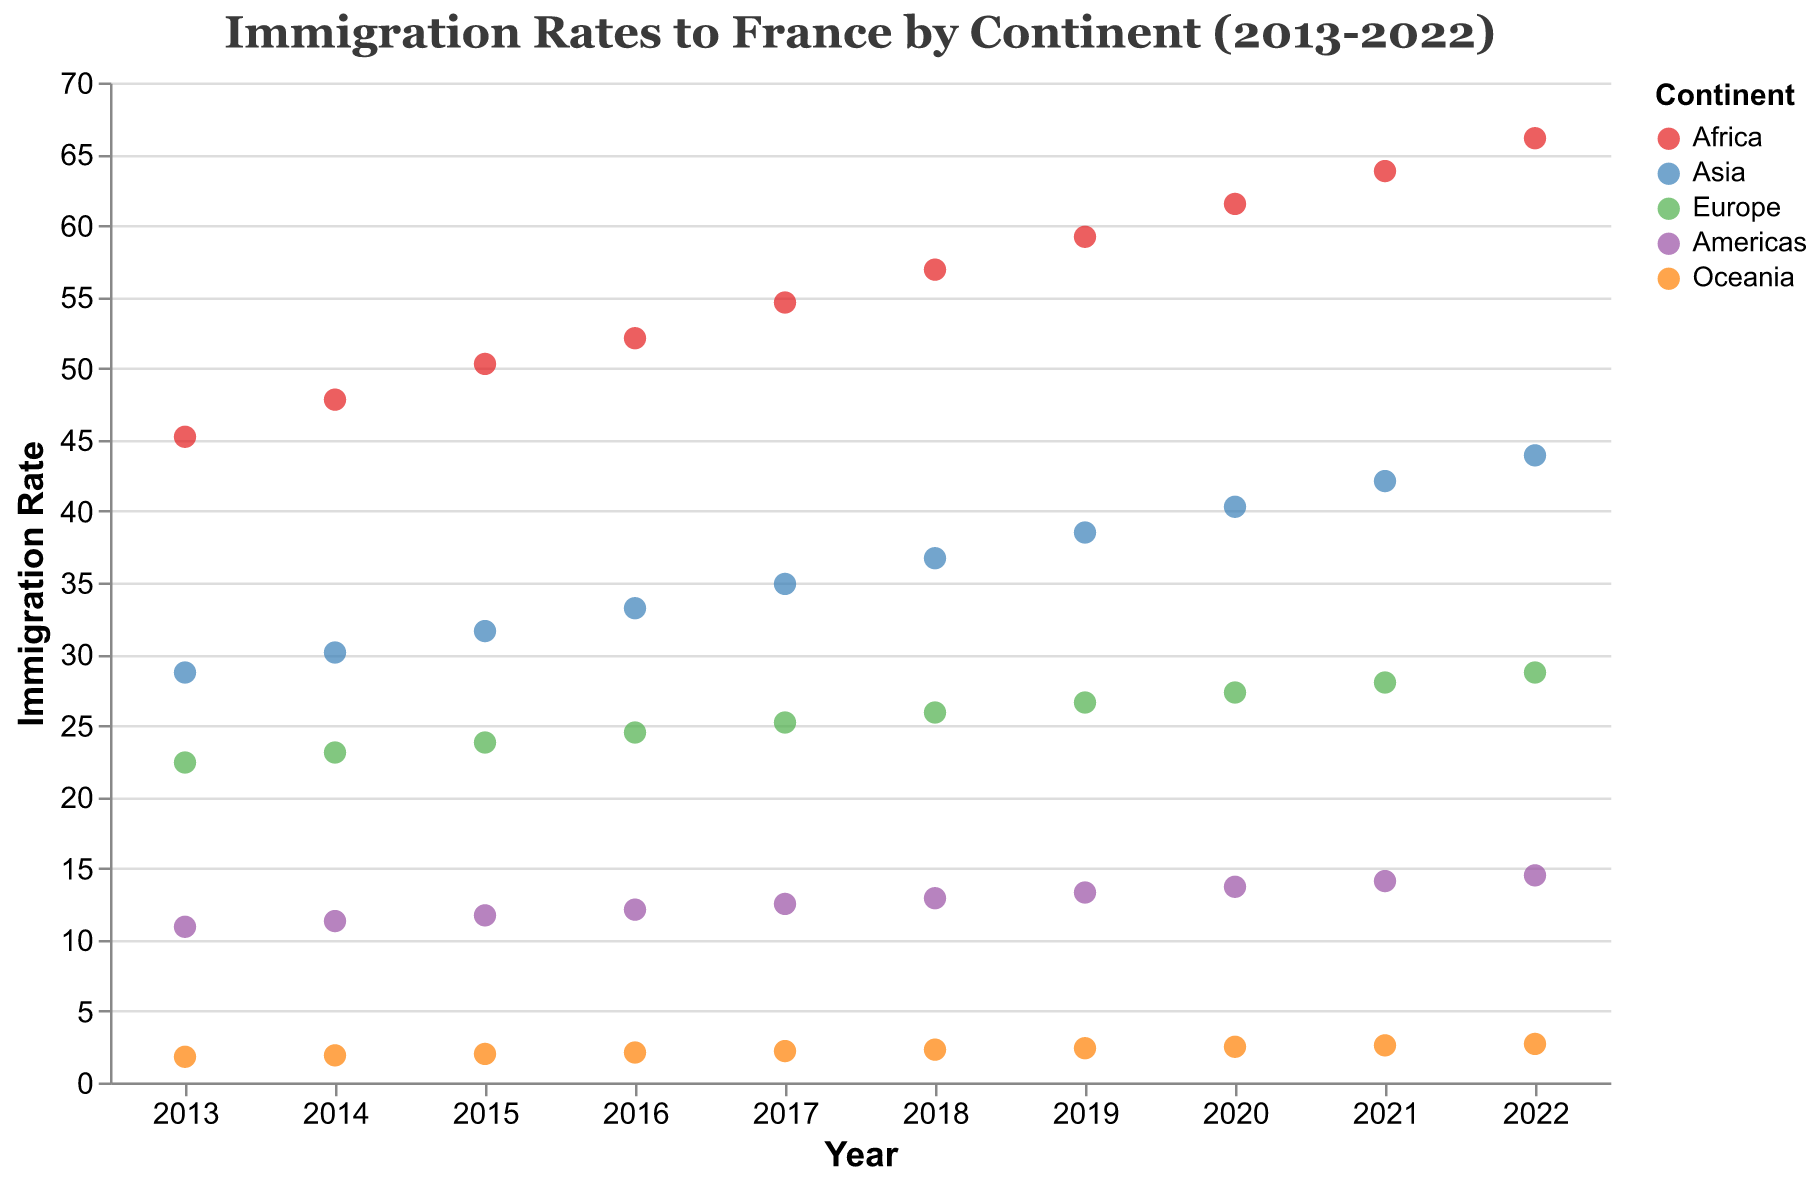What is the title of the plot? The title of the plot is displayed at the top-center section of the plot. Here, it reads "Immigration Rates to France by Continent (2013-2022)"
Answer: Immigration Rates to France by Continent (2013-2022) What is the immigration rate from Europe in the year 2016? To find this, look along the x-axis for the year 2016, then move vertically until you reach the point corresponding to Europe. The plot tooltip will show this value.
Answer: 24.5 Which continent had the lowest immigration rate in 2022? First, identify the year 2022 on the x-axis. Then, examine the points directly above it and identify the one with the lowest y-axis value, which represents the immigration rate.
Answer: Oceania How did the immigration rate from Africa change from 2013 to 2022? Locate the data points for Africa in 2013 and 2022 on the plot. Read and compare their y-axis values to see the change. Immigration rate in 2013 was 45.2 and in 2022 it was 66.1, so the change is calculated as 66.1 - 45.2.
Answer: 20.9 Which two continents had the most similar immigration rates in 2017? Look at the data points for 2017 for all continents. Compare the y-axis values for each set of points and find the two that are closest in value.
Answer: Asia and Europe What is the average immigration rate to France from Asia over the decade (2013-2022)? Sum the immigration rates for Asia from 2013 to 2022, then divide by the number of years (10). Calculation: (28.7 + 30.1 + 31.6 + 33.2 + 34.9 + 36.7 + 38.5 + 40.3 + 42.1 + 43.9) / 10 = 36.00.
Answer: 36.0 By how much did the immigration rate from the Americas increase from 2015 to 2020? Find the immigration rates for the Americas in 2015 and 2020. Subtract the 2015 rate from the 2020 rate. Calculation: 13.7 - 11.7 = 2.0.
Answer: 2.0 Across which years did Oceania experience the highest annual growth rate in immigration? Review the immigration rates for Oceania year by year, noting the difference between each consecutive pair of years. Identify the years with the largest difference.
Answer: 2019-2020 Which continent had a consistent yearly increase in immigration rate over the decade? Evaluate each continent's data points to see if there's a steady increase in their immigration rates year over year. Africa shows a consistent increase across the decade.
Answer: Africa 